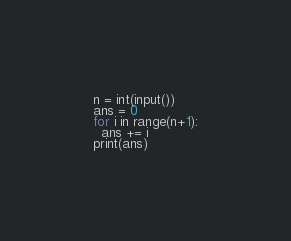<code> <loc_0><loc_0><loc_500><loc_500><_Python_>n = int(input())
ans = 0
for i in range(n+1):
  ans += i
print(ans)
</code> 